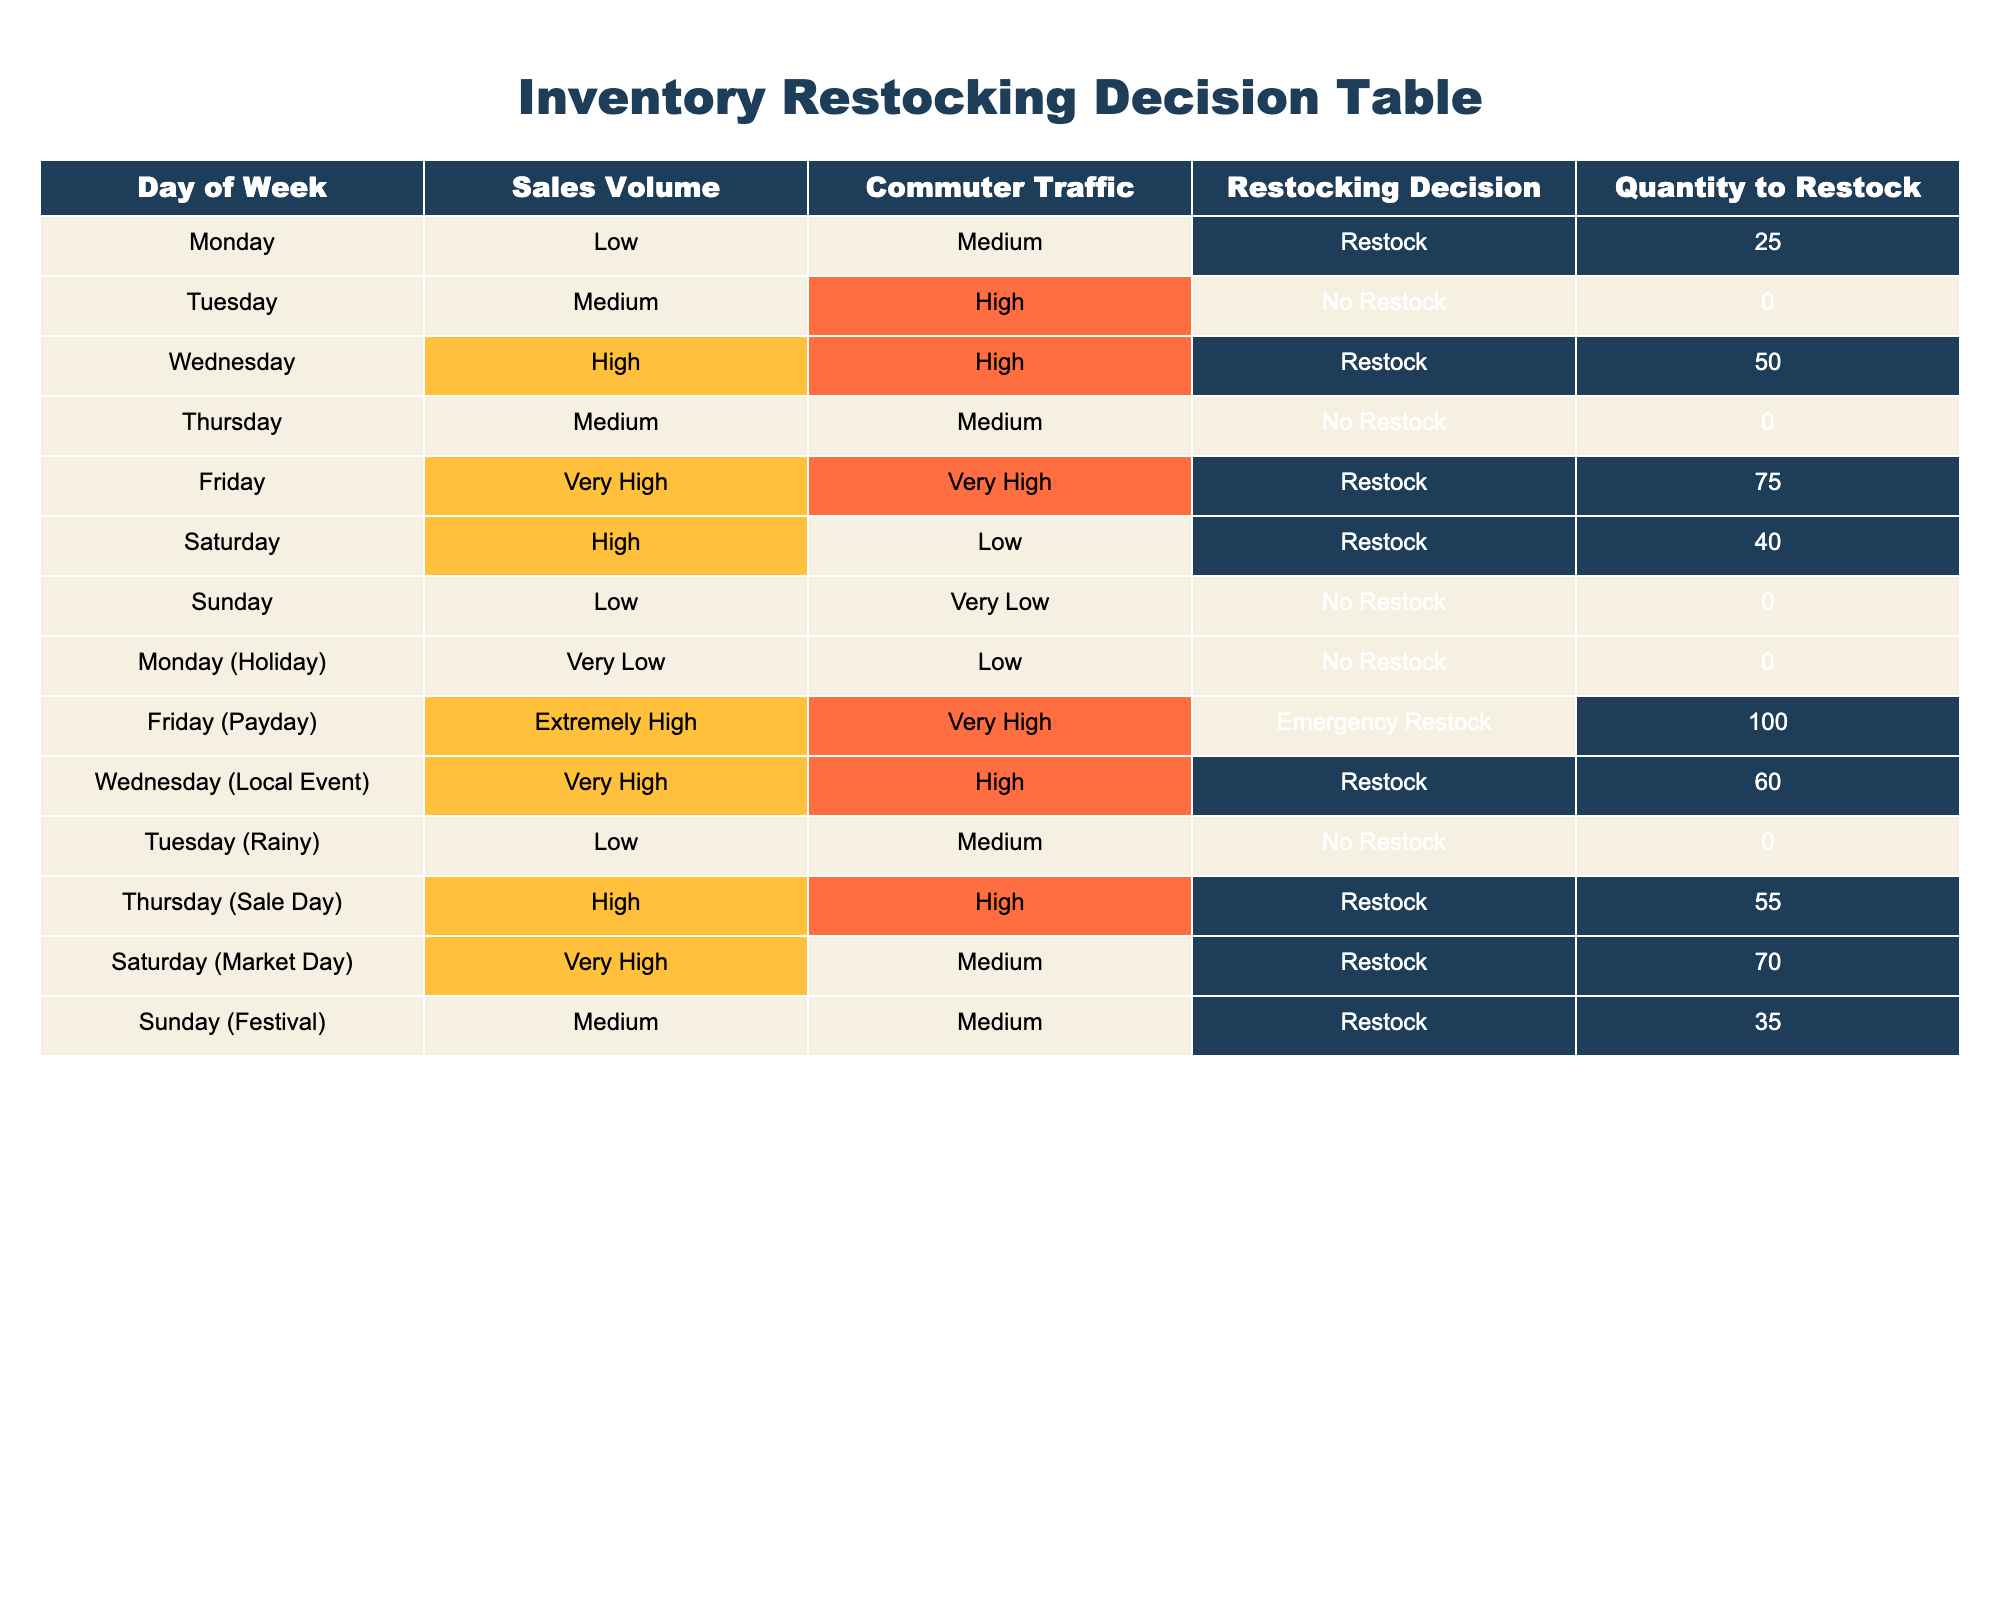What is the quantity to restock on a Friday? On Friday, the restocking decision is "Restock" with a quantity of 75, as indicated in the corresponding row of the table.
Answer: 75 How many days are marked with "No Restock"? By counting the rows in the "Restocking Decision" column that state "No Restock," we find there are four occurrences: Tuesday, Thursday, Sunday, and Monday (Holiday).
Answer: 4 What is the sales volume on Saturday (Market Day)? The table shows that on Saturday (Market Day), the sales volume is "Very High." This information can be found directly in the sales volume column corresponding to Saturday (Market Day).
Answer: Very High Is restocking needed on Wednesday (Local Event)? Yes, on Wednesday (Local Event), the restocking decision is "Restock," which is indicated in the table.
Answer: Yes What is the total quantity to restock for the weekdays (Monday to Friday)? Adding the quantities to restock from Monday (25), Tuesday (0), Wednesday (50), Thursday (0), and Friday (75) gives a total of 150. So, 25 + 0 + 50 + 0 + 75 = 150.
Answer: 150 On which day is the emergency restock decision made, and what is the quantity? The emergency restock decision is made on "Friday (Payday)," with a quantity of 100. This can be confirmed by checking the restocking decision on the row for that specific day.
Answer: Friday (Payday), 100 What is the difference in sales volume between Friday and Sunday? Friday has a sales volume of "Very High," and Sunday has a sales volume of "Low." This indicates a significant difference in sales performance, but to label it numerically or qualitatively, Friday's is higher without a fixed measurable scale in this context.
Answer: Yes, Friday is higher How does commuter traffic on Saturday compare to Thursday? On Saturday, the commuter traffic is "Medium," while on Thursday, it is "Medium" as well, indicating no difference in this specific aspect.
Answer: No difference What is the average quantity to restock on days where the sales volume is "High"? For the days with "High" sales volume (Wednesday, Thursday (Sale Day), Saturday (Market Day)), the quantities are 50, 55, and 70. The average is calculated as (50 + 55 + 70) / 3 = 175 / 3 = 58.33.
Answer: 58.33 